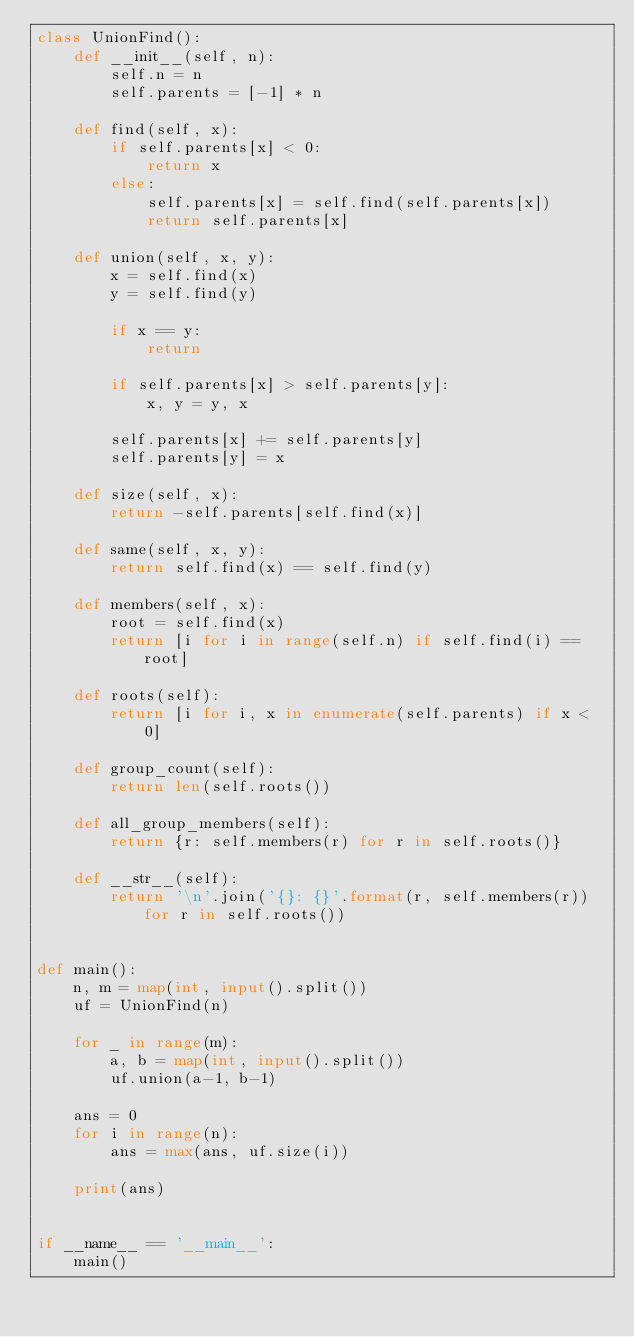<code> <loc_0><loc_0><loc_500><loc_500><_Python_>class UnionFind():
    def __init__(self, n):
        self.n = n
        self.parents = [-1] * n

    def find(self, x):
        if self.parents[x] < 0:
            return x
        else:
            self.parents[x] = self.find(self.parents[x])
            return self.parents[x]

    def union(self, x, y):
        x = self.find(x)
        y = self.find(y)

        if x == y:
            return

        if self.parents[x] > self.parents[y]:
            x, y = y, x

        self.parents[x] += self.parents[y]
        self.parents[y] = x

    def size(self, x):
        return -self.parents[self.find(x)]

    def same(self, x, y):
        return self.find(x) == self.find(y)

    def members(self, x):
        root = self.find(x)
        return [i for i in range(self.n) if self.find(i) == root]

    def roots(self):
        return [i for i, x in enumerate(self.parents) if x < 0]

    def group_count(self):
        return len(self.roots())

    def all_group_members(self):
        return {r: self.members(r) for r in self.roots()}

    def __str__(self):
        return '\n'.join('{}: {}'.format(r, self.members(r)) for r in self.roots())


def main():
    n, m = map(int, input().split())
    uf = UnionFind(n)

    for _ in range(m):
        a, b = map(int, input().split())
        uf.union(a-1, b-1)
    
    ans = 0
    for i in range(n):
        ans = max(ans, uf.size(i))
    
    print(ans)


if __name__ == '__main__':
    main()
</code> 